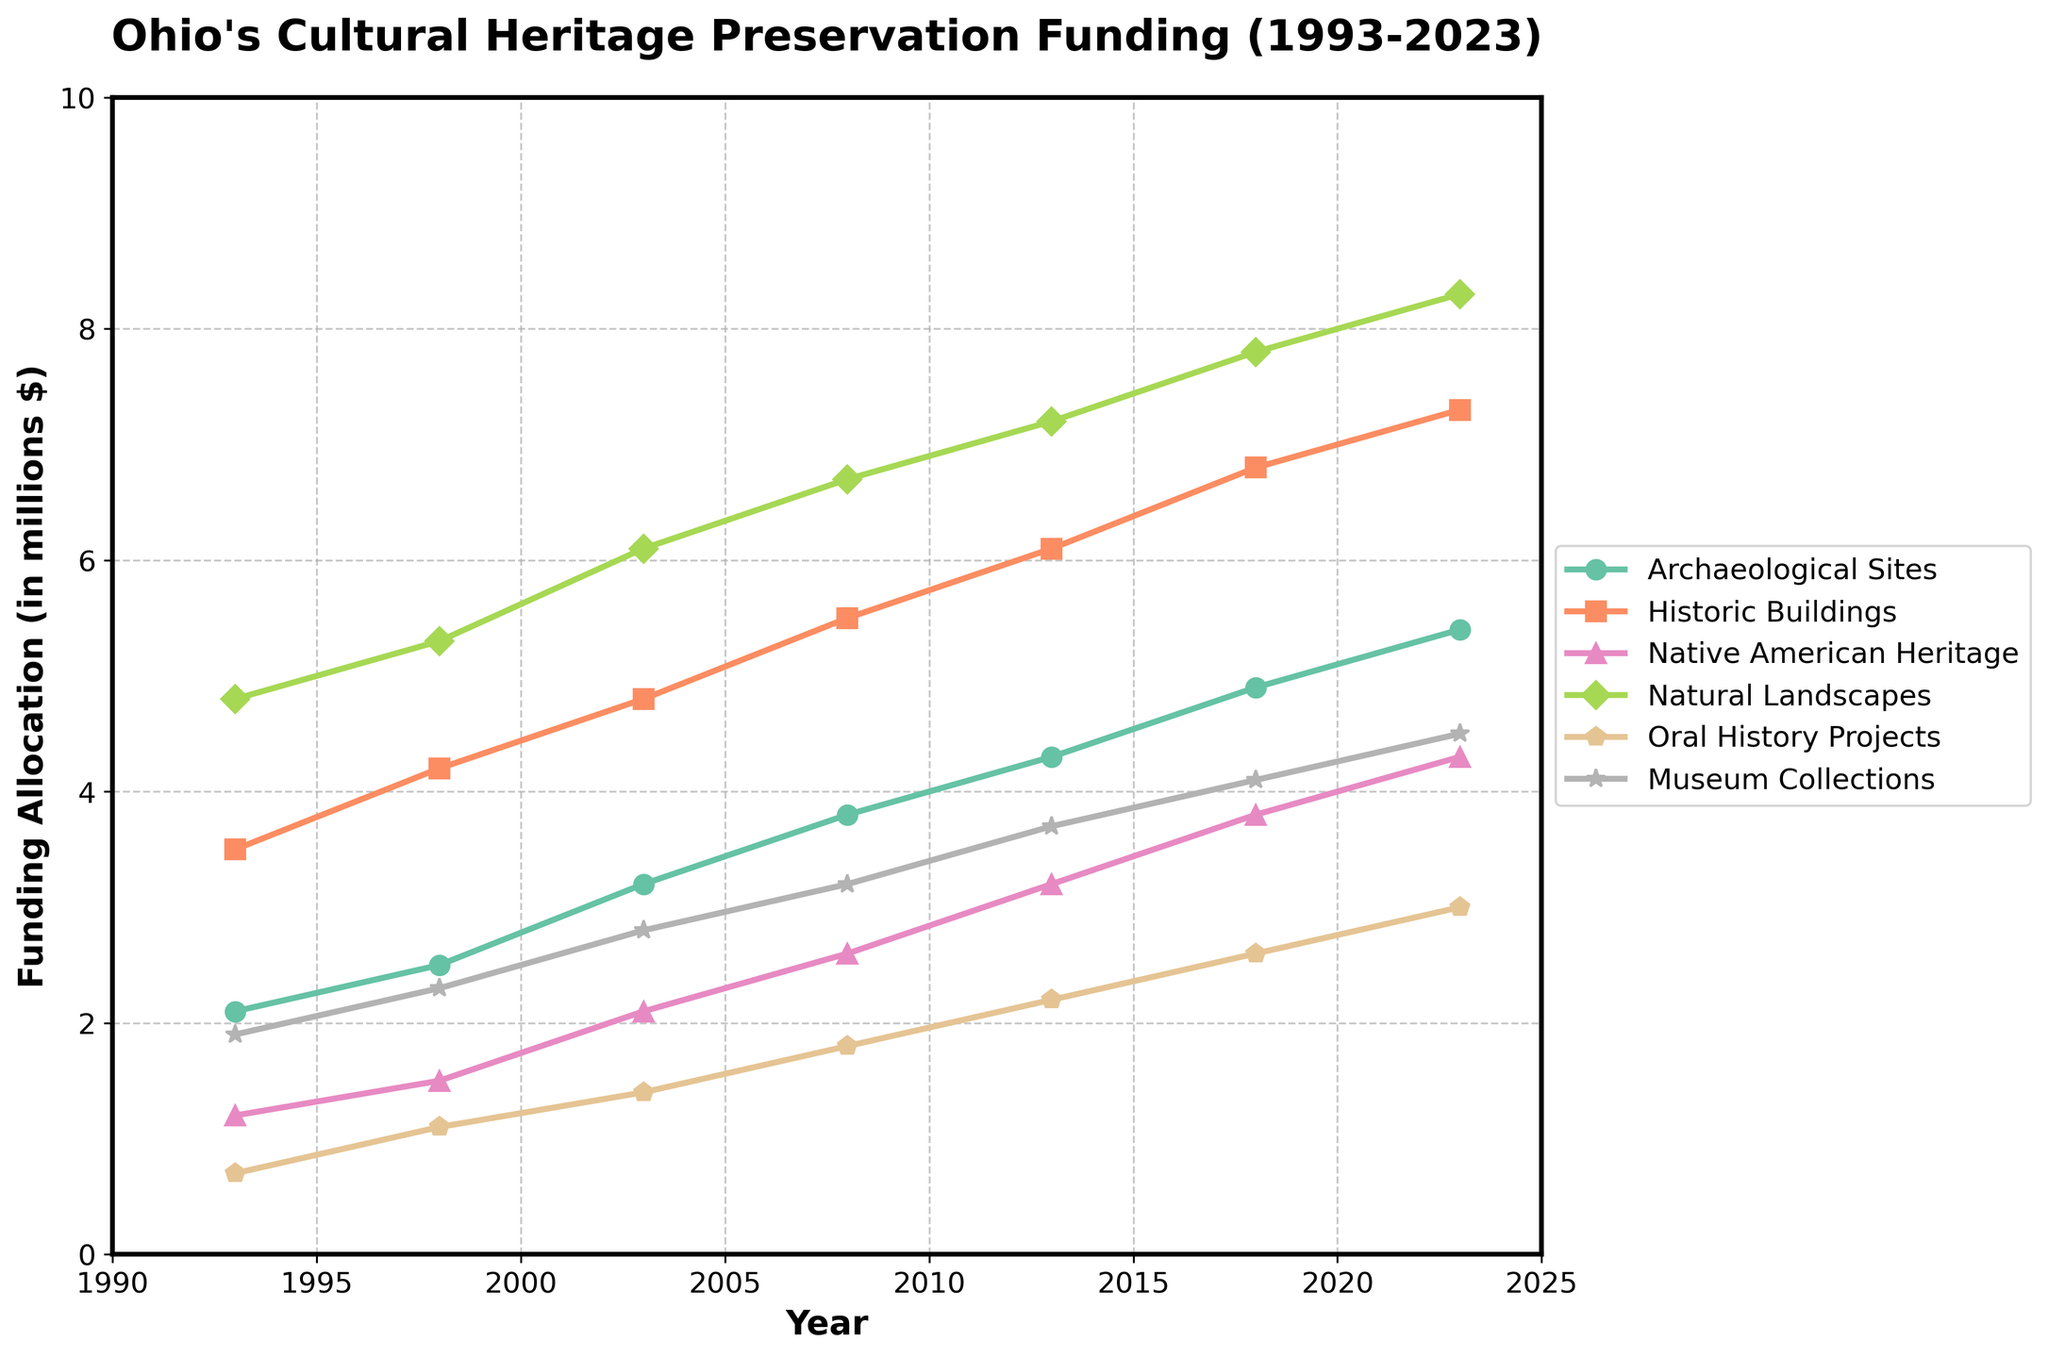How has the funding allocation for Museum Collections changed from 1993 to 2023? Look at the plot and the line for Museum Collections. In 1993, the funding was $1.9 million, and in 2023, it increased to $4.5 million. This shows a steady increase over 30 years.
Answer: Increased by $2.6 million Which project type had the highest funding allocation in 2023? Identify the highest line on the plot in 2023. The Natural Landscapes project had the highest funding with $8.3 million.
Answer: Natural Landscapes Compare the funding growth between Historic Buildings and Oral History Projects from 1993 to 2023. In 1993, the funding for Historic Buildings was $3.5 million and for Oral History Projects was $0.7 million. By 2023, their funding grew to $7.3 million and $3.0 million respectively. The growth for Historic Buildings was $3.8 million, while the growth for Oral History Projects was $2.3 million.
Answer: Historic Buildings had a greater growth What was the average funding allocation for Native American Heritage projects over the entire period? Add the funding values for Native American Heritage from each year: 1.2 + 1.5 + 2.1 + 2.6 + 3.2 + 3.8 + 4.3 = 18.7. Divide by the number of years (7): $18.7\text{ million} / 7$ years = $2.671\text{ million}$.
Answer: $2.671 million$ Which project type had the least funding allocation in 2008 and how much was it? Check the lines for 2008 and find the lowest point. Oral History Projects had the least funding with $1.8 million.
Answer: Oral History Projects with $1.8 million In what year did funding for Archaeological Sites surpass $4 million for the first time? Follow the line for Archaeological Sites. It first surpasses $4 million in 2013.
Answer: 2013 What is the total funding allocated to Historic Buildings over the 30 years? Add the funding amounts for Historic Buildings: 3.5 + 4.2 + 4.8 + 5.5 + 6.1 + 6.8 + 7.3 = $38.2 million.
Answer: $38.2 million How does the funding trend for Natural Landscapes compare to Native American Heritage over the years? Look at both lines. Natural Landscapes start at 4.8 in 1993 and steadily rise to 8.3 in 2023. Native American Heritage start from 1.2 and rise to 4.3. Natural Landscapes consistently received more funding and had a steeper increase.
Answer: Natural Landscapes consistently higher and steeper increase 